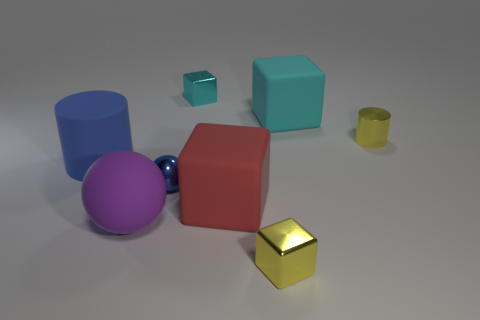What is the color of the small object behind the large block that is behind the cylinder to the right of the tiny yellow block?
Ensure brevity in your answer.  Cyan. Is there a purple sphere that is left of the object in front of the big matte sphere?
Keep it short and to the point. Yes. Do the cylinder to the left of the red thing and the tiny metal cube that is in front of the big matte cylinder have the same color?
Your response must be concise. No. How many other blue shiny things have the same size as the blue shiny thing?
Your answer should be very brief. 0. Do the yellow block on the right side of the blue cylinder and the tiny blue shiny object have the same size?
Provide a short and direct response. Yes. What is the shape of the red object?
Provide a succinct answer. Cube. What is the size of the metal cube that is the same color as the metallic cylinder?
Keep it short and to the point. Small. Do the big blue object that is behind the purple sphere and the large ball have the same material?
Keep it short and to the point. Yes. Is there a big ball that has the same color as the big matte cylinder?
Keep it short and to the point. No. There is a small yellow object in front of the tiny cylinder; is it the same shape as the blue shiny object that is left of the big cyan cube?
Your answer should be compact. No. 